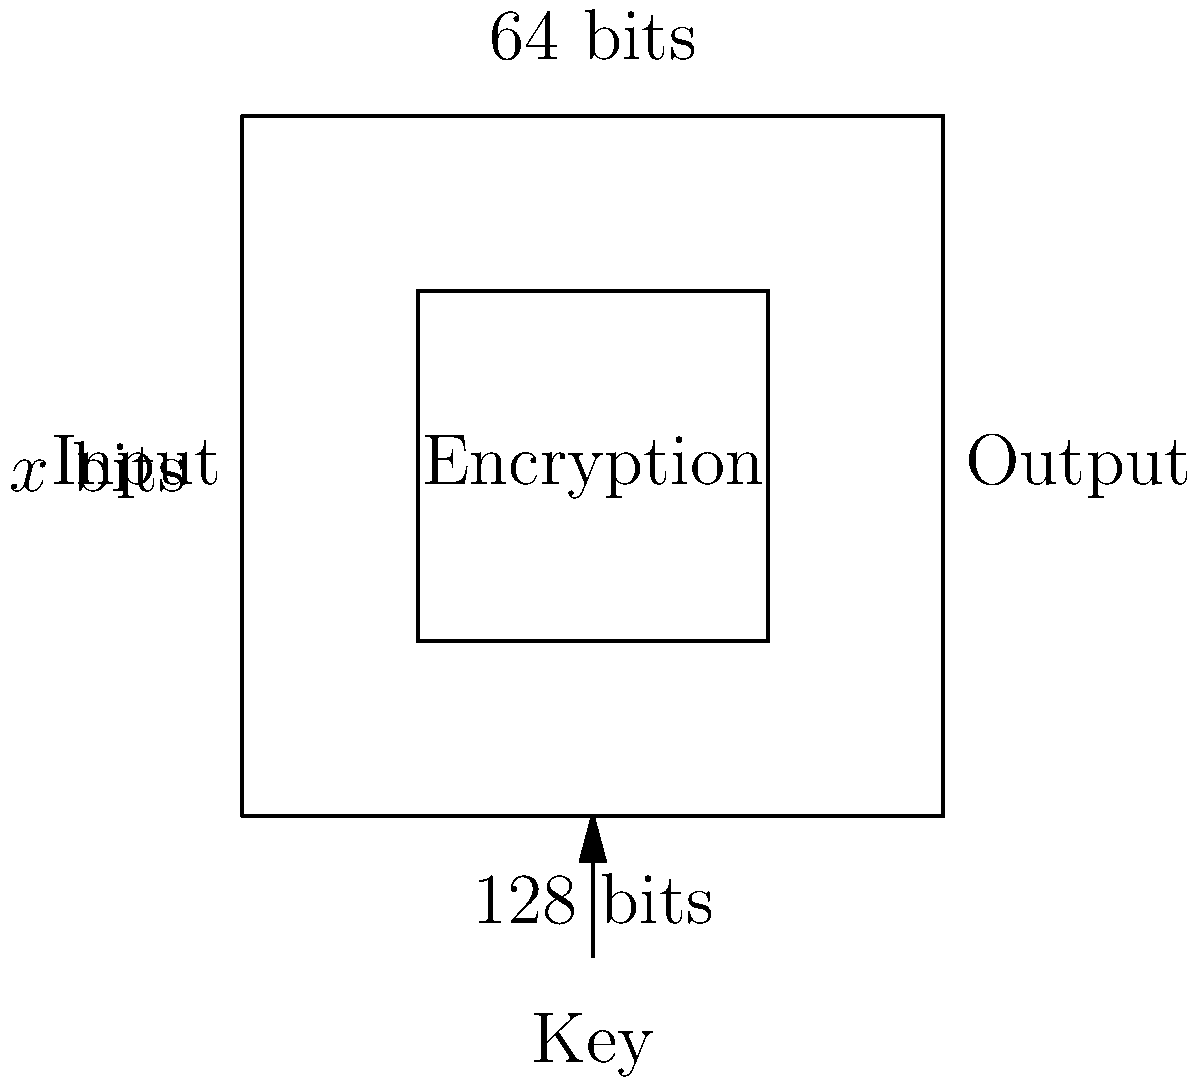Given the encryption algorithm diagram above, where the input and output are both 64 bits, and the key length is 128 bits, calculate the length of the encryption key in bytes. How many possible unique keys are there? To solve this problem, we need to follow these steps:

1. Identify the key length in bits:
   The diagram shows that the key length is 128 bits.

2. Convert bits to bytes:
   1 byte = 8 bits
   $128 \div 8 = 16$ bytes

3. Calculate the number of possible unique keys:
   For each bit, there are 2 possible values (0 or 1).
   With 128 bits, we have $2^{128}$ possible combinations.

   $2^{128} = 340,282,366,920,938,463,463,374,607,431,768,211,456$

This extremely large number of possible keys makes it computationally infeasible for an attacker to try all combinations, ensuring the security of the encryption algorithm.
Answer: 16 bytes; $2^{128}$ possible keys 